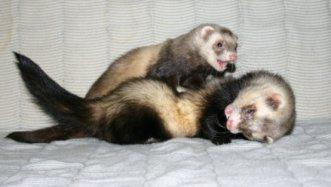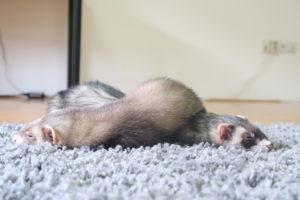The first image is the image on the left, the second image is the image on the right. Evaluate the accuracy of this statement regarding the images: "At least two ferrets are playing.". Is it true? Answer yes or no. Yes. 